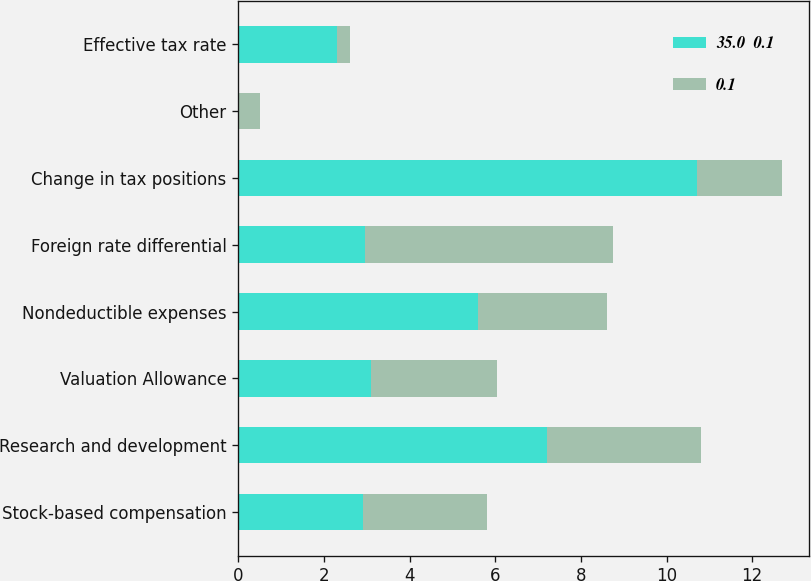<chart> <loc_0><loc_0><loc_500><loc_500><stacked_bar_chart><ecel><fcel>Stock-based compensation<fcel>Research and development<fcel>Valuation Allowance<fcel>Nondeductible expenses<fcel>Foreign rate differential<fcel>Change in tax positions<fcel>Other<fcel>Effective tax rate<nl><fcel>35.0  0.1<fcel>2.9<fcel>7.2<fcel>3.1<fcel>5.6<fcel>2.95<fcel>10.7<fcel>0<fcel>2.3<nl><fcel>0.1<fcel>2.9<fcel>3.6<fcel>2.95<fcel>3<fcel>5.8<fcel>2<fcel>0.5<fcel>0.3<nl></chart> 